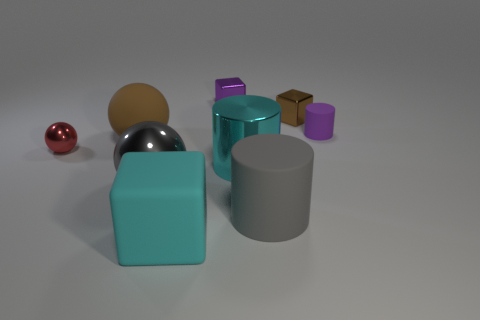What can you say about the lighting in the scene? The lighting in the scene appears to be diffused, with a soft shadow cast below and to the right of the objects, suggesting that the light source is coming from the top left side of the frame. The smooth surfaces of some objects have strong highlights, indicating a fairly bright light source, but the shadows are not harsh so the light may be somewhat scattered. 